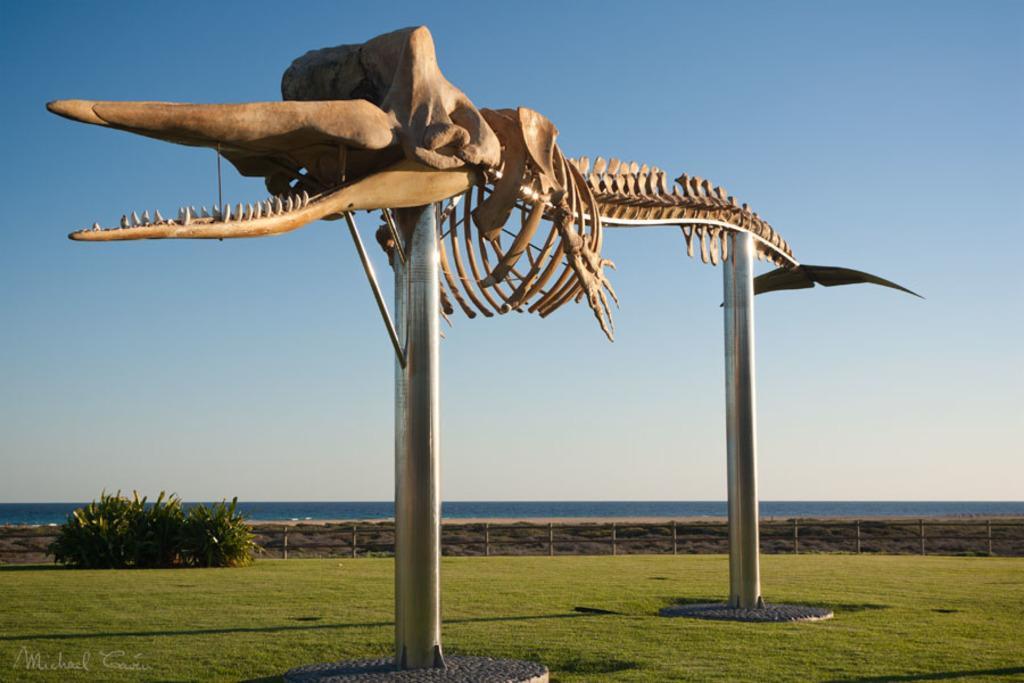Could you give a brief overview of what you see in this image? In this picture there is a skeleton of dinosaur on the rods and there is grass land at the bottom side of the image. 